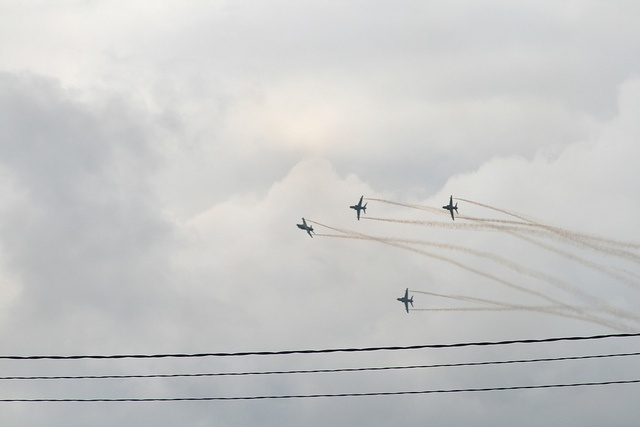Describe the objects in this image and their specific colors. I can see airplane in lightgray, gray, blue, darkgray, and darkblue tones, airplane in lightgray, black, gray, purple, and darkblue tones, airplane in lightgray, blue, purple, and darkgray tones, and airplane in lightgray, gray, purple, and darkblue tones in this image. 